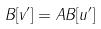Convert formula to latex. <formula><loc_0><loc_0><loc_500><loc_500>B [ v ^ { \prime } ] = A B [ u ^ { \prime } ]</formula> 